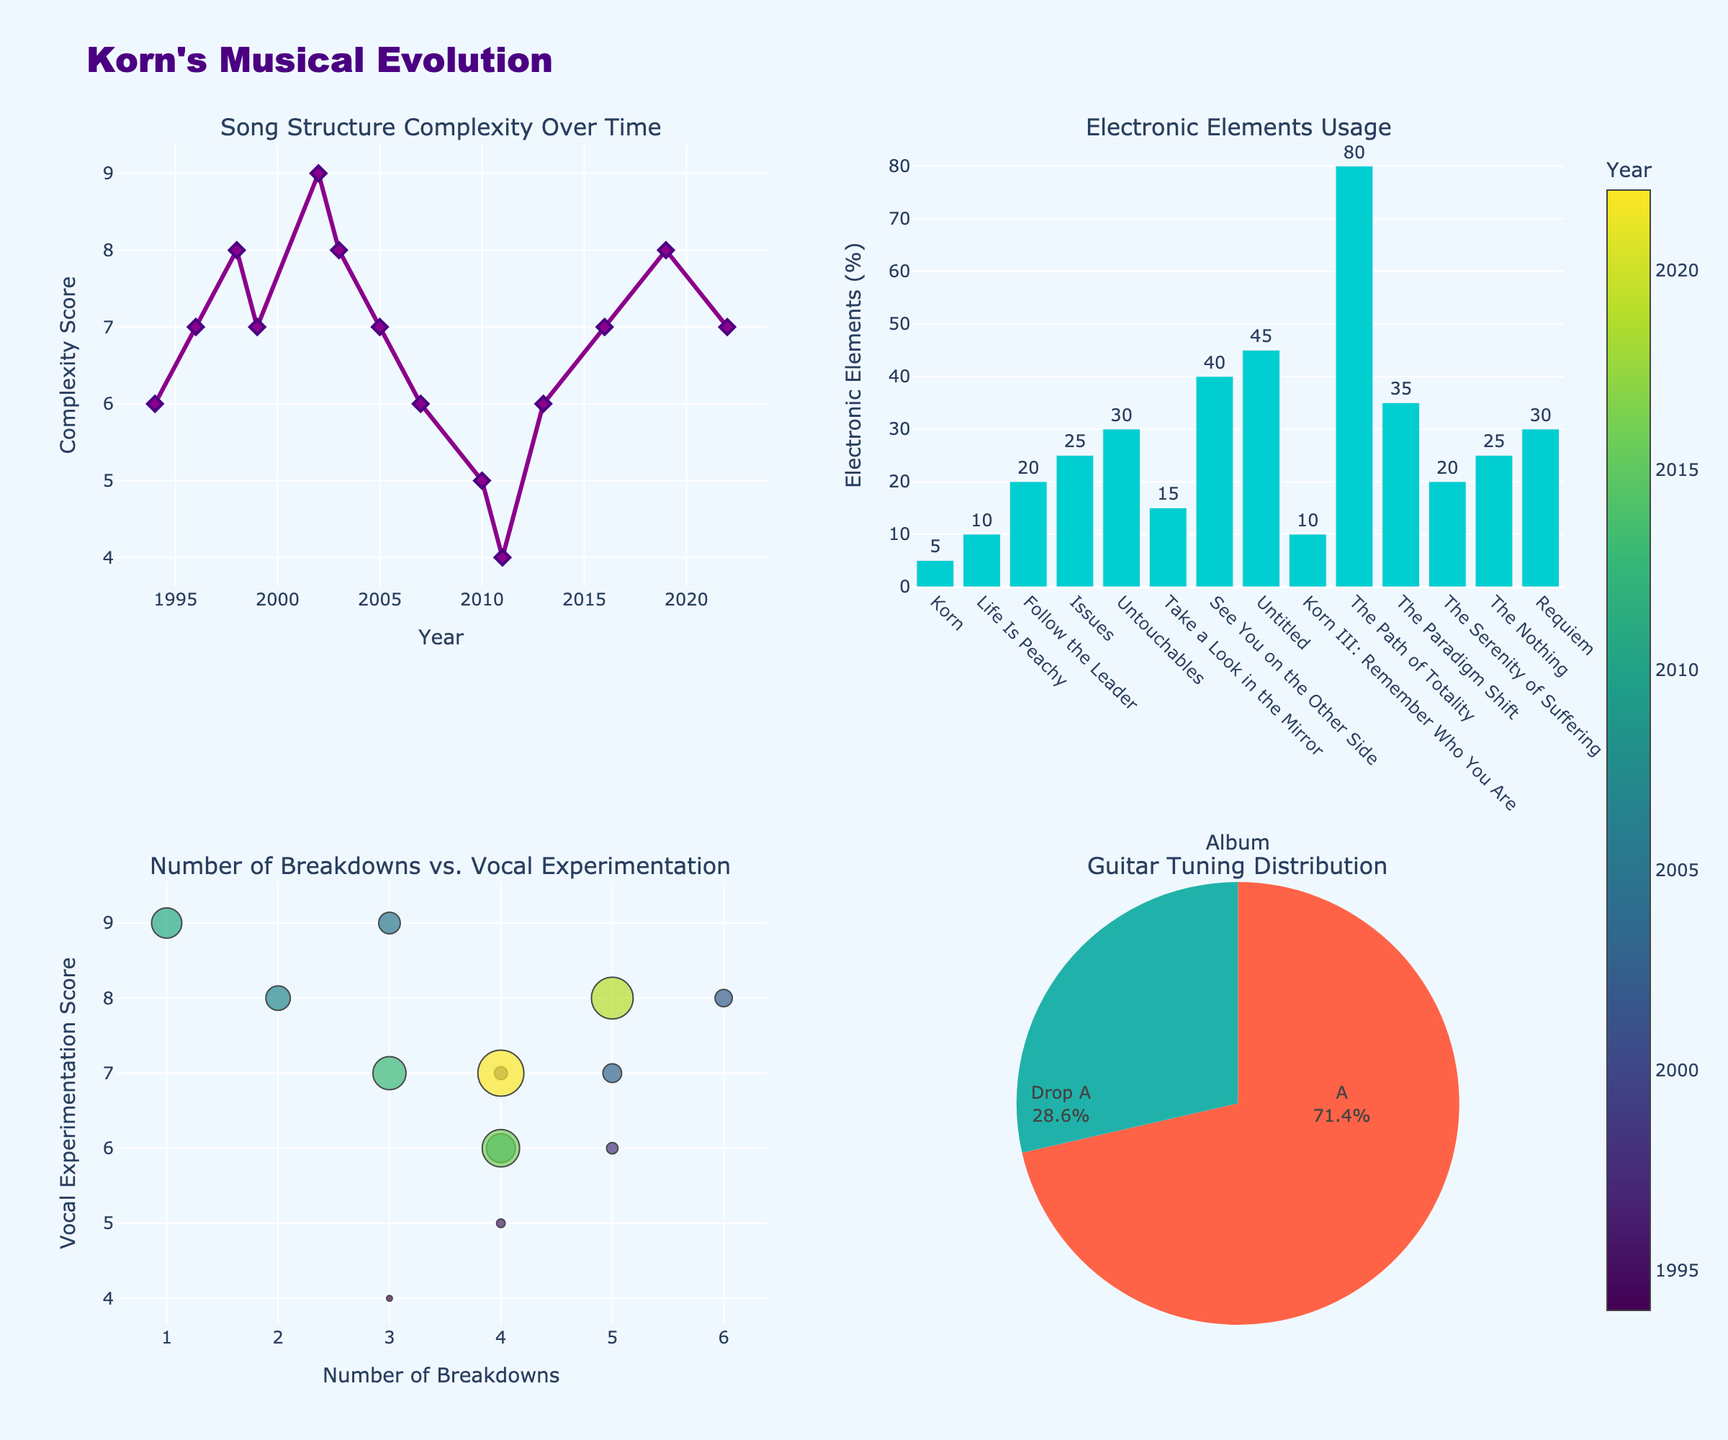What are the age groups displayed in the figure? The age groups displayed in the figure are mentioned along the x-axis.
Answer: 18-29, 30-44, 45-64, 65+ What is the overall title of the figure? The overall title is located at the top center of the figure.
Answer: Prevalence of Chronic Diseases Across Age Groups Which disease has the highest prevalence in the 65+ age group? By looking at the heights of the bars for the 65+ age group in the figure, the tallest bar corresponds to Arthritis.
Answer: Arthritis How does the prevalence of Hypertension change as age increases? By observing the bars for Hypertension across the different age groups, the height of the bars increases consistently as the age group progresses from 18-29 to 65+.
Answer: It increases Which age group has the lowest prevalence of Heart Disease? The bar for Heart Disease in the 18-29 age group is the shortest compared to the other age groups.
Answer: 18-29 What is the difference in Diabetes prevalence between the 30-44 and 45-64 age groups? The prevalence of Diabetes in the 30-44 age group is 4.6 and in the 45-64 age group is 12.8. The difference is 12.8 - 4.6.
Answer: 8.2 Compare the prevalence of Obesity in the 30-44 and 45-64 age groups. Which one is higher? By comparing the heights of the bars for Obesity in the 30-44 and 45-64 age groups, the height is higher for the 45-64 age group.
Answer: 45-64 Among the displayed diseases, which one shows a decreasing trend after the 45-64 age group? Analyzing the bars for each disease shows that Obesity decreases from the 45-64 to the 65+ age group.
Answer: Obesity What is the sum of prevalence percentages for Arthritis across all age groups? Adding the prevalence percentages: 6.3 (18-29) + 15.2 (30-44) + 29.8 (45-64) + 49.6 (65+).
Answer: 100.9 What is the average prevalence of Hypertension across all age groups? Adding the prevalence percentages: 5.2 (18-29) + 13.7 (30-44) + 37.5 (45-64) + 63.1 (65+) = 119.5, then dividing by 4 (number of age groups) = 119.5 / 4.
Answer: 29.875 Which diseases exhibit a prevalence percentage between 20% and 50% in the 45-64 age group? By examining the heights of the bars in the 45-64 age group, Hypertension (37.5), Obesity (42.8), and Arthritis (29.8) fit within the range of 20% to 50%.
Answer: Hypertension, Obesity, Arthritis 